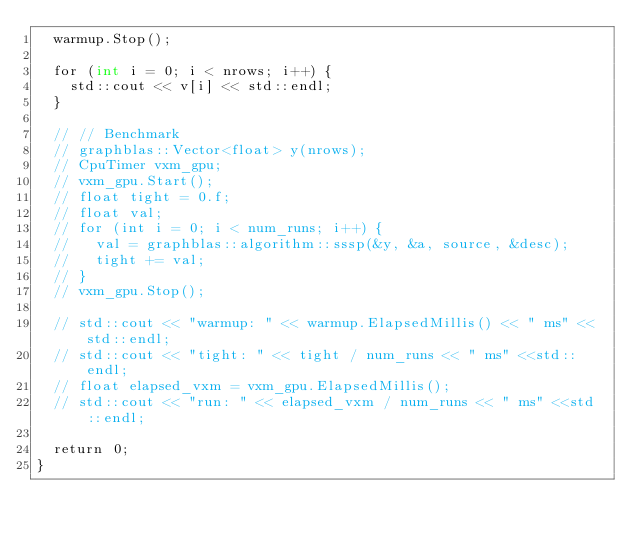<code> <loc_0><loc_0><loc_500><loc_500><_Cuda_>  warmup.Stop();

  for (int i = 0; i < nrows; i++) {
    std::cout << v[i] << std::endl;
  }

  // // Benchmark
  // graphblas::Vector<float> y(nrows);
  // CpuTimer vxm_gpu;
  // vxm_gpu.Start();
  // float tight = 0.f;
  // float val;
  // for (int i = 0; i < num_runs; i++) {
  //   val = graphblas::algorithm::sssp(&y, &a, source, &desc);
  //   tight += val;
  // }
  // vxm_gpu.Stop();

  // std::cout << "warmup: " << warmup.ElapsedMillis() << " ms" <<std::endl;
  // std::cout << "tight: " << tight / num_runs << " ms" <<std::endl;
  // float elapsed_vxm = vxm_gpu.ElapsedMillis();
  // std::cout << "run: " << elapsed_vxm / num_runs << " ms" <<std::endl;

  return 0;
}
</code> 